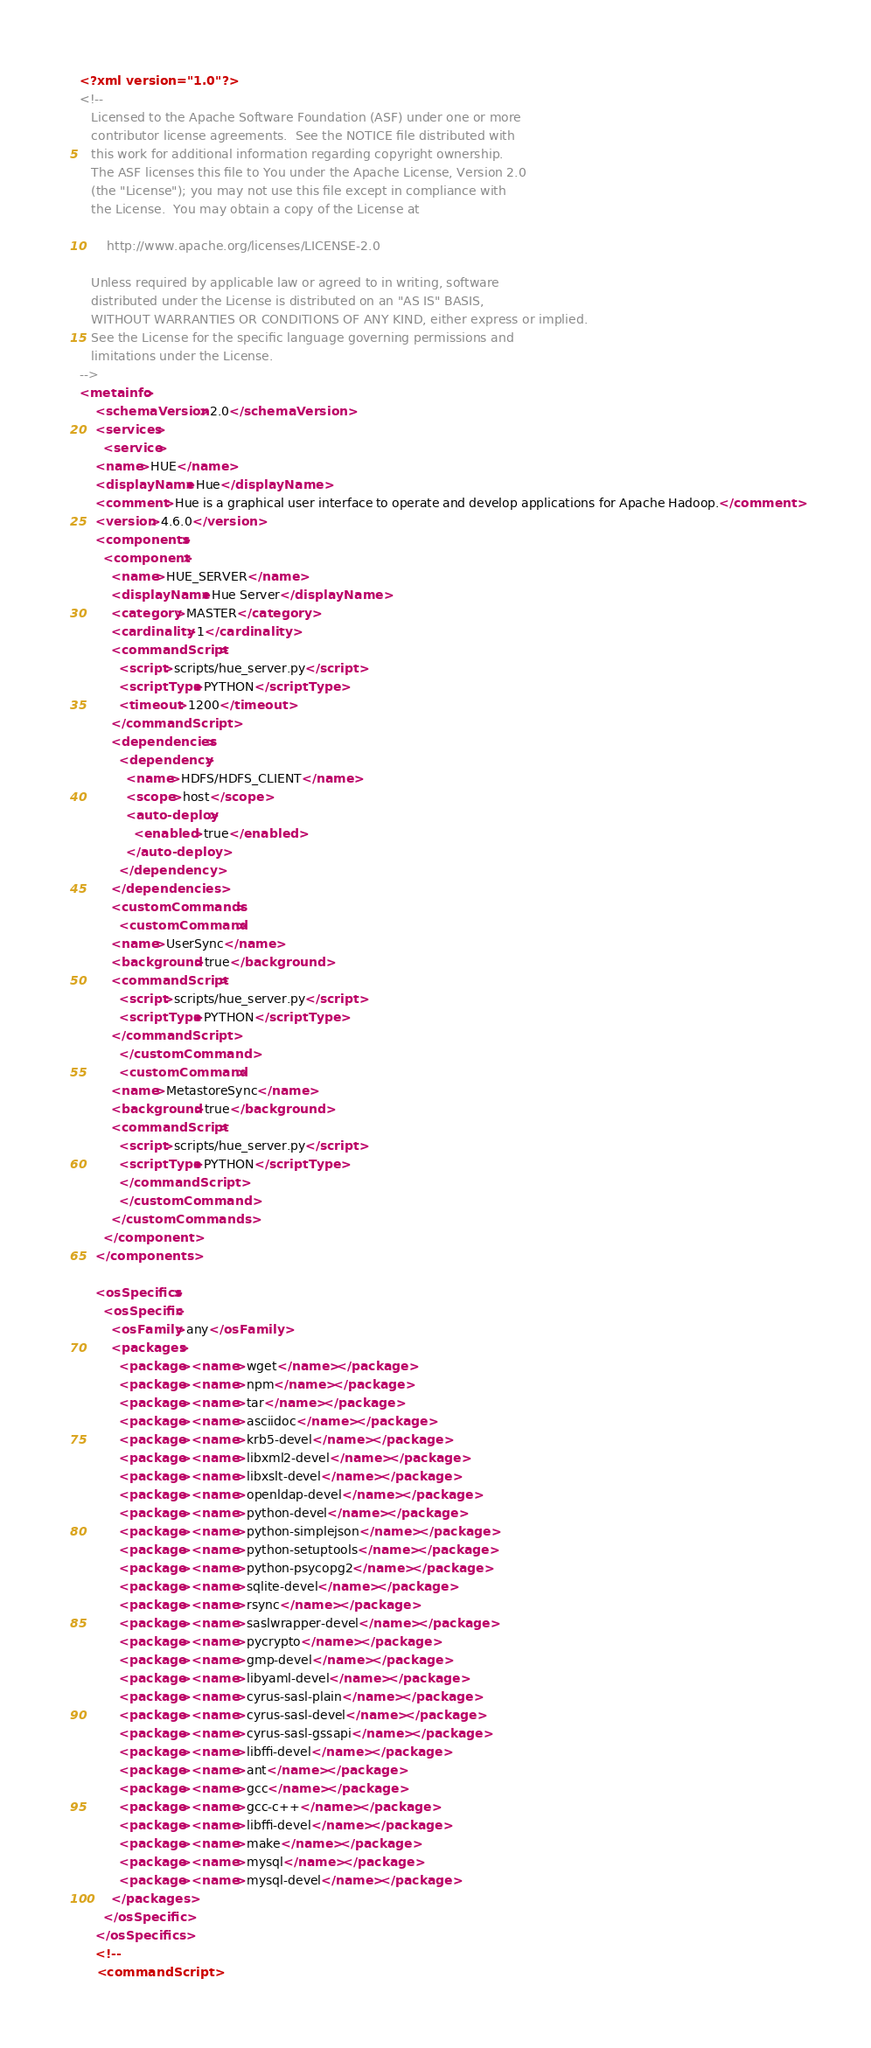Convert code to text. <code><loc_0><loc_0><loc_500><loc_500><_XML_><?xml version="1.0"?>
<!--
   Licensed to the Apache Software Foundation (ASF) under one or more
   contributor license agreements.  See the NOTICE file distributed with
   this work for additional information regarding copyright ownership.
   The ASF licenses this file to You under the Apache License, Version 2.0
   (the "License"); you may not use this file except in compliance with
   the License.  You may obtain a copy of the License at

       http://www.apache.org/licenses/LICENSE-2.0

   Unless required by applicable law or agreed to in writing, software
   distributed under the License is distributed on an "AS IS" BASIS,
   WITHOUT WARRANTIES OR CONDITIONS OF ANY KIND, either express or implied.
   See the License for the specific language governing permissions and
   limitations under the License.
-->
<metainfo>
    <schemaVersion>2.0</schemaVersion>
    <services>
      <service>
	<name>HUE</name>
	<displayName>Hue</displayName>
    <comment>Hue is a graphical user interface to operate and develop applications for Apache Hadoop.</comment>
	<version>4.6.0</version>
	<components>
	  <component>
	    <name>HUE_SERVER</name>
	    <displayName>Hue Server</displayName>
	    <category>MASTER</category>
	    <cardinality>1</cardinality>
	    <commandScript>
	      <script>scripts/hue_server.py</script>
	      <scriptType>PYTHON</scriptType>
	      <timeout>1200</timeout>
	    </commandScript>
	    <dependencies>
          <dependency>
            <name>HDFS/HDFS_CLIENT</name>
            <scope>host</scope>
            <auto-deploy>
              <enabled>true</enabled>
            </auto-deploy>
          </dependency>
        </dependencies>
	    <customCommands>
	      <customCommand>
		<name>UserSync</name>
		<background>true</background>
		<commandScript>
		  <script>scripts/hue_server.py</script>
		  <scriptType>PYTHON</scriptType>
		</commandScript>
	      </customCommand>
	      <customCommand>
		<name>MetastoreSync</name>
		<background>true</background>
		<commandScript>
		  <script>scripts/hue_server.py</script>
		  <scriptType>PYTHON</scriptType>
		  </commandScript>
	      </customCommand>
	    </customCommands>
	  </component>
	</components>

	<osSpecifics>
	  <osSpecific>
	    <osFamily>any</osFamily>
	    <packages>
	      <package><name>wget</name></package>   
	      <package><name>npm</name></package>
	      <package><name>tar</name></package>
	      <package><name>asciidoc</name></package>
	      <package><name>krb5-devel</name></package>
	      <package><name>libxml2-devel</name></package>
	      <package><name>libxslt-devel</name></package>		   
	      <package><name>openldap-devel</name></package>
	      <package><name>python-devel</name></package>
	      <package><name>python-simplejson</name></package>
	      <package><name>python-setuptools</name></package>
	      <package><name>python-psycopg2</name></package>
	      <package><name>sqlite-devel</name></package>
	      <package><name>rsync</name></package>
	      <package><name>saslwrapper-devel</name></package>
	      <package><name>pycrypto</name></package>
	      <package><name>gmp-devel</name></package>
	      <package><name>libyaml-devel</name></package>
	      <package><name>cyrus-sasl-plain</name></package>
	      <package><name>cyrus-sasl-devel</name></package>
	      <package><name>cyrus-sasl-gssapi</name></package>
	      <package><name>libffi-devel</name></package>
	      <package><name>ant</name></package>
	      <package><name>gcc</name></package>
	      <package><name>gcc-c++</name></package>
	      <package><name>libffi-devel</name></package>
	      <package><name>make</name></package>
	      <package><name>mysql</name></package>
	      <package><name>mysql-devel</name></package>
        </packages>
	  </osSpecific>
	</osSpecifics>
	<!--
	<commandScript></code> 